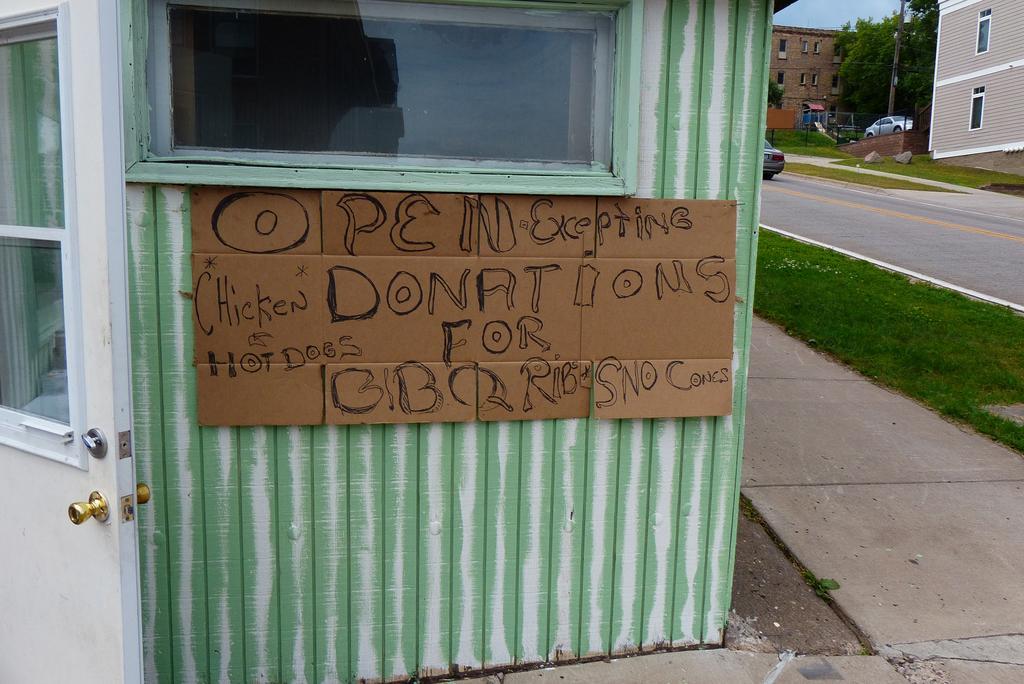Could you give a brief overview of what you see in this image? In this picture we can see some text on the cardboard, in the background we can see grass, few buildings, trees and vehicles. 